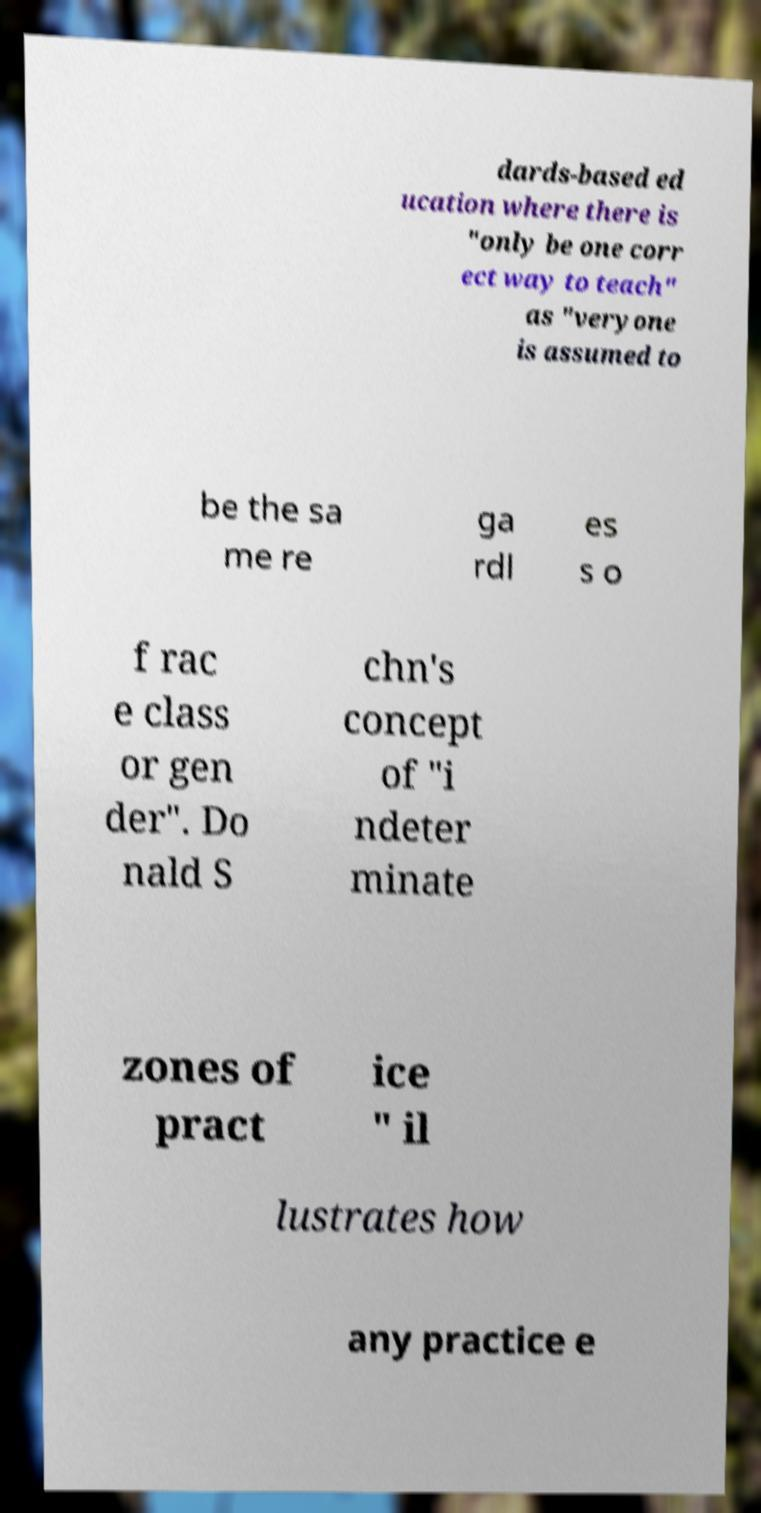Could you extract and type out the text from this image? dards-based ed ucation where there is "only be one corr ect way to teach" as "veryone is assumed to be the sa me re ga rdl es s o f rac e class or gen der". Do nald S chn's concept of "i ndeter minate zones of pract ice " il lustrates how any practice e 